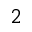Convert formula to latex. <formula><loc_0><loc_0><loc_500><loc_500>^ { 2 }</formula> 